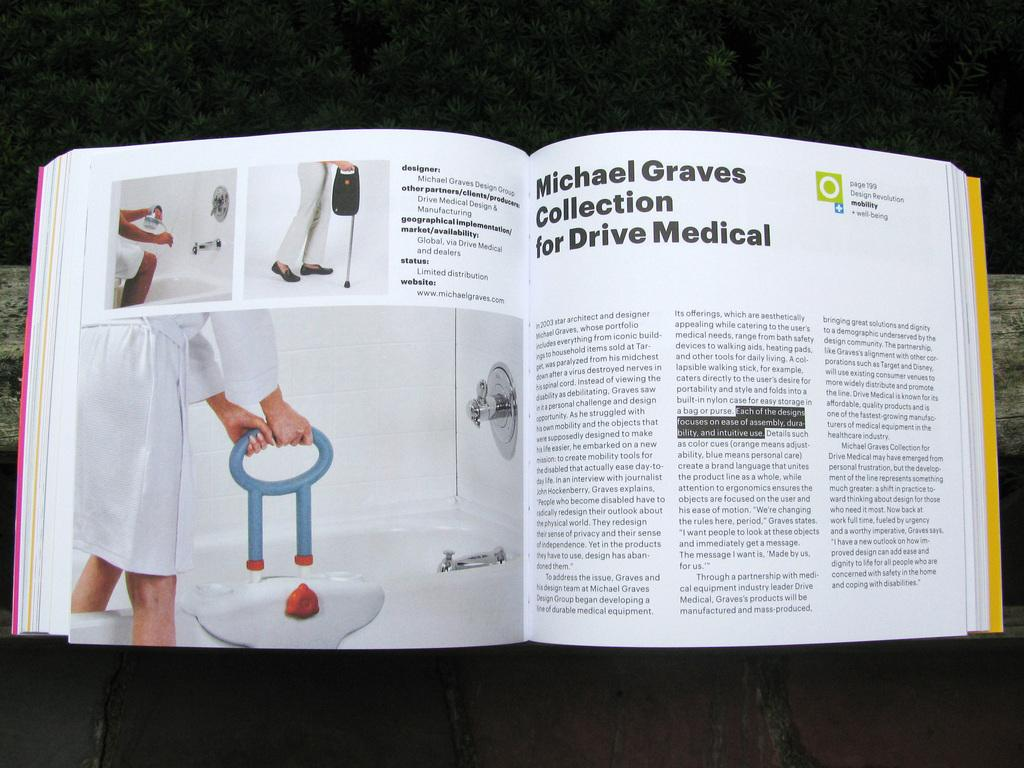What is present in the image related to reading material? There is a book in the image. What type of content can be found in the book? The book contains pictures and text. Can you see a request being made in the image? There is no request visible in the image; it only features a book with pictures and text. Is there a heart-shaped object present in the image? There is no heart-shaped object present in the image. How many potatoes are visible in the image? There are no potatoes visible in the image. 